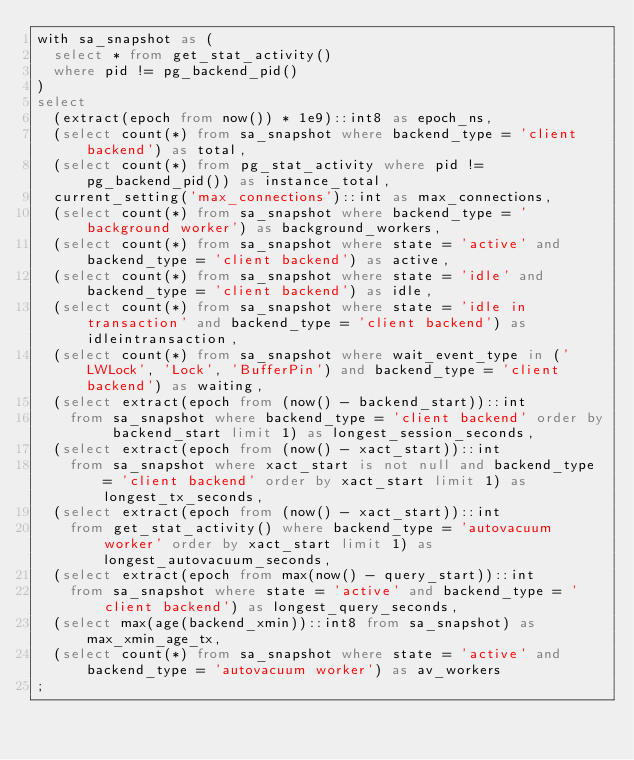Convert code to text. <code><loc_0><loc_0><loc_500><loc_500><_SQL_>with sa_snapshot as (
  select * from get_stat_activity()
  where pid != pg_backend_pid()
)
select
  (extract(epoch from now()) * 1e9)::int8 as epoch_ns,
  (select count(*) from sa_snapshot where backend_type = 'client backend') as total,
  (select count(*) from pg_stat_activity where pid != pg_backend_pid()) as instance_total,
  current_setting('max_connections')::int as max_connections,
  (select count(*) from sa_snapshot where backend_type = 'background worker') as background_workers,
  (select count(*) from sa_snapshot where state = 'active' and backend_type = 'client backend') as active,
  (select count(*) from sa_snapshot where state = 'idle' and backend_type = 'client backend') as idle,
  (select count(*) from sa_snapshot where state = 'idle in transaction' and backend_type = 'client backend') as idleintransaction,
  (select count(*) from sa_snapshot where wait_event_type in ('LWLock', 'Lock', 'BufferPin') and backend_type = 'client backend') as waiting,
  (select extract(epoch from (now() - backend_start))::int
    from sa_snapshot where backend_type = 'client backend' order by backend_start limit 1) as longest_session_seconds,
  (select extract(epoch from (now() - xact_start))::int
    from sa_snapshot where xact_start is not null and backend_type = 'client backend' order by xact_start limit 1) as longest_tx_seconds,
  (select extract(epoch from (now() - xact_start))::int
    from get_stat_activity() where backend_type = 'autovacuum worker' order by xact_start limit 1) as longest_autovacuum_seconds,
  (select extract(epoch from max(now() - query_start))::int
    from sa_snapshot where state = 'active' and backend_type = 'client backend') as longest_query_seconds,
  (select max(age(backend_xmin))::int8 from sa_snapshot) as max_xmin_age_tx,
  (select count(*) from sa_snapshot where state = 'active' and backend_type = 'autovacuum worker') as av_workers
;
</code> 